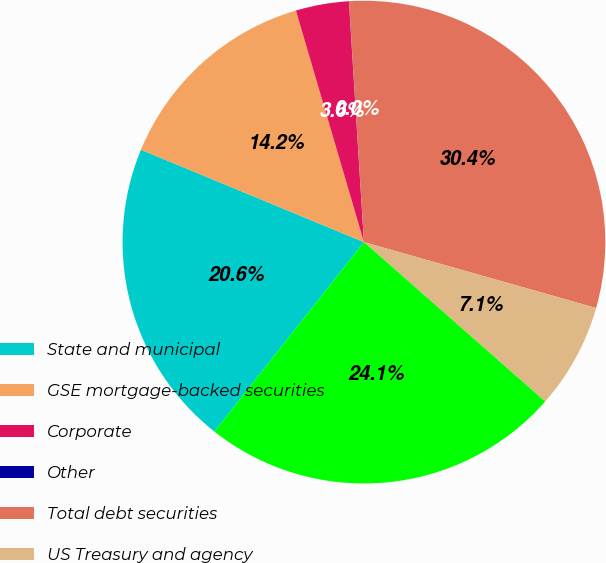<chart> <loc_0><loc_0><loc_500><loc_500><pie_chart><fcel>State and municipal<fcel>GSE mortgage-backed securities<fcel>Corporate<fcel>Other<fcel>Total debt securities<fcel>US Treasury and agency<fcel>GSE mortgage-backed and CMO<nl><fcel>20.62%<fcel>14.2%<fcel>3.55%<fcel>0.01%<fcel>30.39%<fcel>7.08%<fcel>24.15%<nl></chart> 